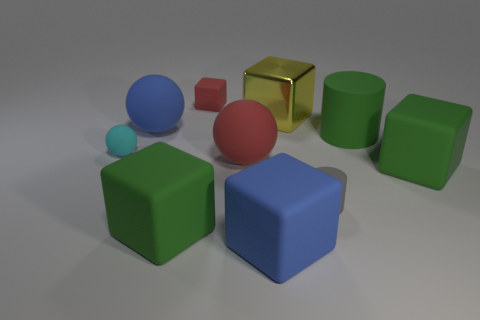Subtract all gray cylinders. How many green blocks are left? 2 Subtract all green blocks. How many blocks are left? 3 Subtract 1 balls. How many balls are left? 2 Subtract all green rubber blocks. How many blocks are left? 3 Subtract all purple cubes. Subtract all brown balls. How many cubes are left? 5 Subtract all spheres. How many objects are left? 7 Subtract 1 green blocks. How many objects are left? 9 Subtract all small brown balls. Subtract all cyan matte objects. How many objects are left? 9 Add 8 big matte spheres. How many big matte spheres are left? 10 Add 9 cyan matte objects. How many cyan matte objects exist? 10 